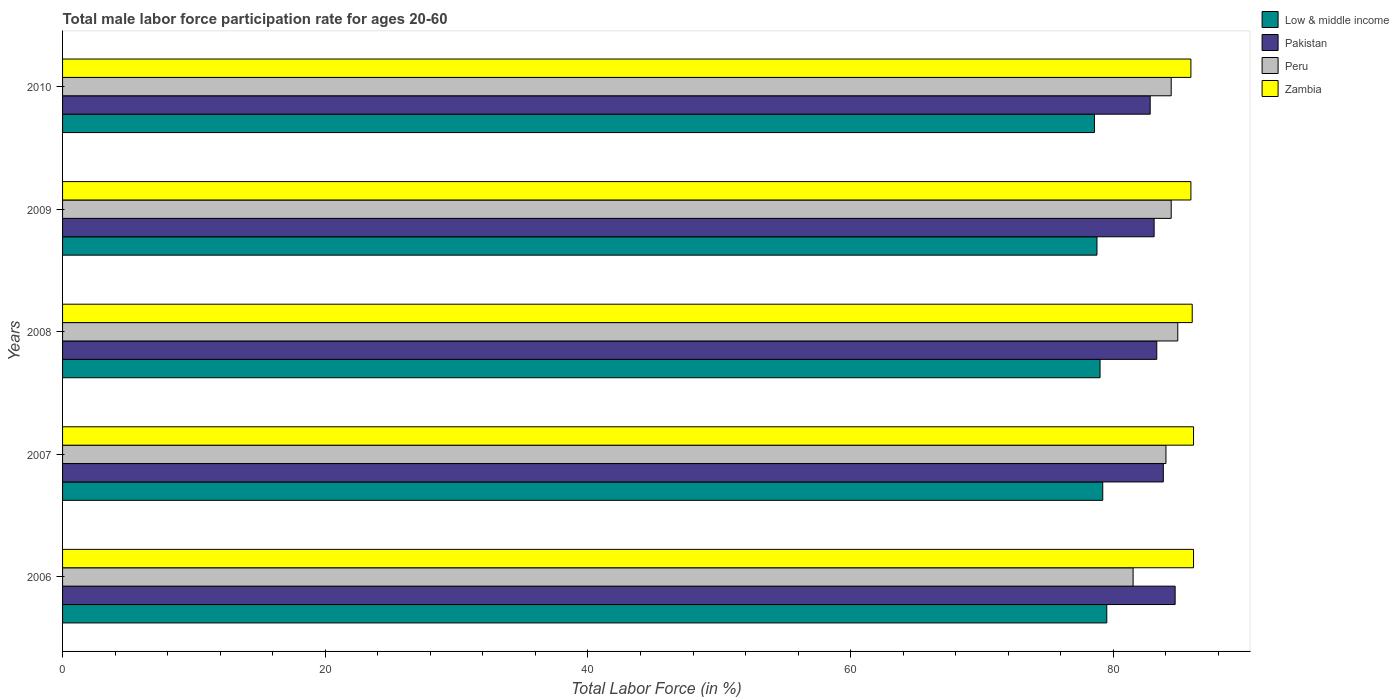How many different coloured bars are there?
Your answer should be very brief. 4. What is the label of the 4th group of bars from the top?
Offer a very short reply. 2007. What is the male labor force participation rate in Zambia in 2010?
Ensure brevity in your answer.  85.9. Across all years, what is the maximum male labor force participation rate in Peru?
Your answer should be compact. 84.9. Across all years, what is the minimum male labor force participation rate in Low & middle income?
Make the answer very short. 78.55. What is the total male labor force participation rate in Low & middle income in the graph?
Provide a short and direct response. 394.97. What is the difference between the male labor force participation rate in Zambia in 2008 and that in 2009?
Ensure brevity in your answer.  0.1. What is the difference between the male labor force participation rate in Zambia in 2008 and the male labor force participation rate in Pakistan in 2007?
Give a very brief answer. 2.2. What is the average male labor force participation rate in Peru per year?
Offer a terse response. 83.84. In the year 2007, what is the difference between the male labor force participation rate in Peru and male labor force participation rate in Zambia?
Your answer should be very brief. -2.1. What is the ratio of the male labor force participation rate in Pakistan in 2006 to that in 2008?
Keep it short and to the point. 1.02. What is the difference between the highest and the lowest male labor force participation rate in Zambia?
Make the answer very short. 0.2. In how many years, is the male labor force participation rate in Peru greater than the average male labor force participation rate in Peru taken over all years?
Your answer should be compact. 4. Is the sum of the male labor force participation rate in Low & middle income in 2006 and 2007 greater than the maximum male labor force participation rate in Pakistan across all years?
Give a very brief answer. Yes. Is it the case that in every year, the sum of the male labor force participation rate in Zambia and male labor force participation rate in Pakistan is greater than the sum of male labor force participation rate in Low & middle income and male labor force participation rate in Peru?
Your answer should be very brief. No. What does the 1st bar from the top in 2006 represents?
Provide a succinct answer. Zambia. What does the 4th bar from the bottom in 2007 represents?
Offer a very short reply. Zambia. Are all the bars in the graph horizontal?
Provide a succinct answer. Yes. How many years are there in the graph?
Your response must be concise. 5. What is the difference between two consecutive major ticks on the X-axis?
Offer a very short reply. 20. Are the values on the major ticks of X-axis written in scientific E-notation?
Your answer should be very brief. No. Does the graph contain grids?
Offer a terse response. No. How many legend labels are there?
Keep it short and to the point. 4. How are the legend labels stacked?
Give a very brief answer. Vertical. What is the title of the graph?
Your response must be concise. Total male labor force participation rate for ages 20-60. What is the label or title of the X-axis?
Ensure brevity in your answer.  Total Labor Force (in %). What is the label or title of the Y-axis?
Your answer should be very brief. Years. What is the Total Labor Force (in %) in Low & middle income in 2006?
Offer a very short reply. 79.5. What is the Total Labor Force (in %) of Pakistan in 2006?
Offer a terse response. 84.7. What is the Total Labor Force (in %) in Peru in 2006?
Keep it short and to the point. 81.5. What is the Total Labor Force (in %) of Zambia in 2006?
Your response must be concise. 86.1. What is the Total Labor Force (in %) in Low & middle income in 2007?
Offer a very short reply. 79.19. What is the Total Labor Force (in %) in Pakistan in 2007?
Offer a very short reply. 83.8. What is the Total Labor Force (in %) of Peru in 2007?
Make the answer very short. 84. What is the Total Labor Force (in %) in Zambia in 2007?
Ensure brevity in your answer.  86.1. What is the Total Labor Force (in %) of Low & middle income in 2008?
Your answer should be very brief. 78.98. What is the Total Labor Force (in %) in Pakistan in 2008?
Offer a very short reply. 83.3. What is the Total Labor Force (in %) of Peru in 2008?
Your answer should be very brief. 84.9. What is the Total Labor Force (in %) of Zambia in 2008?
Your answer should be very brief. 86. What is the Total Labor Force (in %) of Low & middle income in 2009?
Your answer should be compact. 78.75. What is the Total Labor Force (in %) in Pakistan in 2009?
Provide a short and direct response. 83.1. What is the Total Labor Force (in %) of Peru in 2009?
Your answer should be compact. 84.4. What is the Total Labor Force (in %) in Zambia in 2009?
Your answer should be very brief. 85.9. What is the Total Labor Force (in %) of Low & middle income in 2010?
Provide a succinct answer. 78.55. What is the Total Labor Force (in %) of Pakistan in 2010?
Provide a succinct answer. 82.8. What is the Total Labor Force (in %) in Peru in 2010?
Make the answer very short. 84.4. What is the Total Labor Force (in %) of Zambia in 2010?
Make the answer very short. 85.9. Across all years, what is the maximum Total Labor Force (in %) in Low & middle income?
Provide a succinct answer. 79.5. Across all years, what is the maximum Total Labor Force (in %) in Pakistan?
Offer a very short reply. 84.7. Across all years, what is the maximum Total Labor Force (in %) in Peru?
Provide a succinct answer. 84.9. Across all years, what is the maximum Total Labor Force (in %) in Zambia?
Make the answer very short. 86.1. Across all years, what is the minimum Total Labor Force (in %) of Low & middle income?
Offer a terse response. 78.55. Across all years, what is the minimum Total Labor Force (in %) of Pakistan?
Offer a terse response. 82.8. Across all years, what is the minimum Total Labor Force (in %) of Peru?
Offer a terse response. 81.5. Across all years, what is the minimum Total Labor Force (in %) of Zambia?
Your response must be concise. 85.9. What is the total Total Labor Force (in %) in Low & middle income in the graph?
Keep it short and to the point. 394.97. What is the total Total Labor Force (in %) in Pakistan in the graph?
Your response must be concise. 417.7. What is the total Total Labor Force (in %) in Peru in the graph?
Keep it short and to the point. 419.2. What is the total Total Labor Force (in %) of Zambia in the graph?
Give a very brief answer. 430. What is the difference between the Total Labor Force (in %) of Low & middle income in 2006 and that in 2007?
Ensure brevity in your answer.  0.31. What is the difference between the Total Labor Force (in %) of Pakistan in 2006 and that in 2007?
Give a very brief answer. 0.9. What is the difference between the Total Labor Force (in %) in Zambia in 2006 and that in 2007?
Your response must be concise. 0. What is the difference between the Total Labor Force (in %) in Low & middle income in 2006 and that in 2008?
Your answer should be very brief. 0.51. What is the difference between the Total Labor Force (in %) of Peru in 2006 and that in 2008?
Make the answer very short. -3.4. What is the difference between the Total Labor Force (in %) of Low & middle income in 2006 and that in 2009?
Provide a succinct answer. 0.75. What is the difference between the Total Labor Force (in %) of Pakistan in 2006 and that in 2009?
Your answer should be compact. 1.6. What is the difference between the Total Labor Force (in %) of Zambia in 2006 and that in 2009?
Your response must be concise. 0.2. What is the difference between the Total Labor Force (in %) in Low & middle income in 2006 and that in 2010?
Provide a succinct answer. 0.94. What is the difference between the Total Labor Force (in %) in Pakistan in 2006 and that in 2010?
Provide a succinct answer. 1.9. What is the difference between the Total Labor Force (in %) of Low & middle income in 2007 and that in 2008?
Offer a very short reply. 0.2. What is the difference between the Total Labor Force (in %) in Pakistan in 2007 and that in 2008?
Offer a terse response. 0.5. What is the difference between the Total Labor Force (in %) in Zambia in 2007 and that in 2008?
Ensure brevity in your answer.  0.1. What is the difference between the Total Labor Force (in %) of Low & middle income in 2007 and that in 2009?
Your answer should be very brief. 0.44. What is the difference between the Total Labor Force (in %) in Peru in 2007 and that in 2009?
Keep it short and to the point. -0.4. What is the difference between the Total Labor Force (in %) of Low & middle income in 2007 and that in 2010?
Provide a short and direct response. 0.63. What is the difference between the Total Labor Force (in %) of Low & middle income in 2008 and that in 2009?
Your answer should be compact. 0.23. What is the difference between the Total Labor Force (in %) in Peru in 2008 and that in 2009?
Give a very brief answer. 0.5. What is the difference between the Total Labor Force (in %) of Low & middle income in 2008 and that in 2010?
Give a very brief answer. 0.43. What is the difference between the Total Labor Force (in %) of Pakistan in 2008 and that in 2010?
Make the answer very short. 0.5. What is the difference between the Total Labor Force (in %) in Peru in 2008 and that in 2010?
Provide a short and direct response. 0.5. What is the difference between the Total Labor Force (in %) in Low & middle income in 2009 and that in 2010?
Your answer should be very brief. 0.19. What is the difference between the Total Labor Force (in %) of Zambia in 2009 and that in 2010?
Offer a very short reply. 0. What is the difference between the Total Labor Force (in %) in Low & middle income in 2006 and the Total Labor Force (in %) in Pakistan in 2007?
Ensure brevity in your answer.  -4.3. What is the difference between the Total Labor Force (in %) in Low & middle income in 2006 and the Total Labor Force (in %) in Peru in 2007?
Your answer should be very brief. -4.5. What is the difference between the Total Labor Force (in %) in Low & middle income in 2006 and the Total Labor Force (in %) in Zambia in 2007?
Make the answer very short. -6.6. What is the difference between the Total Labor Force (in %) in Pakistan in 2006 and the Total Labor Force (in %) in Zambia in 2007?
Your answer should be compact. -1.4. What is the difference between the Total Labor Force (in %) in Peru in 2006 and the Total Labor Force (in %) in Zambia in 2007?
Offer a very short reply. -4.6. What is the difference between the Total Labor Force (in %) in Low & middle income in 2006 and the Total Labor Force (in %) in Pakistan in 2008?
Ensure brevity in your answer.  -3.8. What is the difference between the Total Labor Force (in %) of Low & middle income in 2006 and the Total Labor Force (in %) of Peru in 2008?
Ensure brevity in your answer.  -5.4. What is the difference between the Total Labor Force (in %) of Low & middle income in 2006 and the Total Labor Force (in %) of Zambia in 2008?
Provide a short and direct response. -6.5. What is the difference between the Total Labor Force (in %) in Pakistan in 2006 and the Total Labor Force (in %) in Peru in 2008?
Offer a very short reply. -0.2. What is the difference between the Total Labor Force (in %) of Pakistan in 2006 and the Total Labor Force (in %) of Zambia in 2008?
Keep it short and to the point. -1.3. What is the difference between the Total Labor Force (in %) in Low & middle income in 2006 and the Total Labor Force (in %) in Pakistan in 2009?
Provide a short and direct response. -3.6. What is the difference between the Total Labor Force (in %) in Low & middle income in 2006 and the Total Labor Force (in %) in Peru in 2009?
Offer a terse response. -4.9. What is the difference between the Total Labor Force (in %) of Low & middle income in 2006 and the Total Labor Force (in %) of Zambia in 2009?
Your response must be concise. -6.4. What is the difference between the Total Labor Force (in %) in Pakistan in 2006 and the Total Labor Force (in %) in Zambia in 2009?
Offer a very short reply. -1.2. What is the difference between the Total Labor Force (in %) in Low & middle income in 2006 and the Total Labor Force (in %) in Pakistan in 2010?
Offer a terse response. -3.3. What is the difference between the Total Labor Force (in %) in Low & middle income in 2006 and the Total Labor Force (in %) in Peru in 2010?
Offer a very short reply. -4.9. What is the difference between the Total Labor Force (in %) of Low & middle income in 2006 and the Total Labor Force (in %) of Zambia in 2010?
Your answer should be very brief. -6.4. What is the difference between the Total Labor Force (in %) of Pakistan in 2006 and the Total Labor Force (in %) of Zambia in 2010?
Your answer should be compact. -1.2. What is the difference between the Total Labor Force (in %) of Low & middle income in 2007 and the Total Labor Force (in %) of Pakistan in 2008?
Keep it short and to the point. -4.11. What is the difference between the Total Labor Force (in %) in Low & middle income in 2007 and the Total Labor Force (in %) in Peru in 2008?
Offer a very short reply. -5.71. What is the difference between the Total Labor Force (in %) of Low & middle income in 2007 and the Total Labor Force (in %) of Zambia in 2008?
Ensure brevity in your answer.  -6.81. What is the difference between the Total Labor Force (in %) in Pakistan in 2007 and the Total Labor Force (in %) in Peru in 2008?
Provide a succinct answer. -1.1. What is the difference between the Total Labor Force (in %) in Peru in 2007 and the Total Labor Force (in %) in Zambia in 2008?
Your answer should be compact. -2. What is the difference between the Total Labor Force (in %) of Low & middle income in 2007 and the Total Labor Force (in %) of Pakistan in 2009?
Your answer should be compact. -3.91. What is the difference between the Total Labor Force (in %) of Low & middle income in 2007 and the Total Labor Force (in %) of Peru in 2009?
Keep it short and to the point. -5.21. What is the difference between the Total Labor Force (in %) of Low & middle income in 2007 and the Total Labor Force (in %) of Zambia in 2009?
Offer a very short reply. -6.71. What is the difference between the Total Labor Force (in %) of Pakistan in 2007 and the Total Labor Force (in %) of Zambia in 2009?
Offer a very short reply. -2.1. What is the difference between the Total Labor Force (in %) in Low & middle income in 2007 and the Total Labor Force (in %) in Pakistan in 2010?
Your response must be concise. -3.61. What is the difference between the Total Labor Force (in %) of Low & middle income in 2007 and the Total Labor Force (in %) of Peru in 2010?
Offer a terse response. -5.21. What is the difference between the Total Labor Force (in %) of Low & middle income in 2007 and the Total Labor Force (in %) of Zambia in 2010?
Provide a succinct answer. -6.71. What is the difference between the Total Labor Force (in %) in Peru in 2007 and the Total Labor Force (in %) in Zambia in 2010?
Make the answer very short. -1.9. What is the difference between the Total Labor Force (in %) in Low & middle income in 2008 and the Total Labor Force (in %) in Pakistan in 2009?
Offer a terse response. -4.12. What is the difference between the Total Labor Force (in %) in Low & middle income in 2008 and the Total Labor Force (in %) in Peru in 2009?
Make the answer very short. -5.42. What is the difference between the Total Labor Force (in %) in Low & middle income in 2008 and the Total Labor Force (in %) in Zambia in 2009?
Give a very brief answer. -6.92. What is the difference between the Total Labor Force (in %) of Pakistan in 2008 and the Total Labor Force (in %) of Peru in 2009?
Provide a short and direct response. -1.1. What is the difference between the Total Labor Force (in %) in Peru in 2008 and the Total Labor Force (in %) in Zambia in 2009?
Give a very brief answer. -1. What is the difference between the Total Labor Force (in %) in Low & middle income in 2008 and the Total Labor Force (in %) in Pakistan in 2010?
Provide a succinct answer. -3.82. What is the difference between the Total Labor Force (in %) of Low & middle income in 2008 and the Total Labor Force (in %) of Peru in 2010?
Your answer should be compact. -5.42. What is the difference between the Total Labor Force (in %) of Low & middle income in 2008 and the Total Labor Force (in %) of Zambia in 2010?
Your response must be concise. -6.92. What is the difference between the Total Labor Force (in %) in Pakistan in 2008 and the Total Labor Force (in %) in Peru in 2010?
Your answer should be very brief. -1.1. What is the difference between the Total Labor Force (in %) in Pakistan in 2008 and the Total Labor Force (in %) in Zambia in 2010?
Keep it short and to the point. -2.6. What is the difference between the Total Labor Force (in %) in Low & middle income in 2009 and the Total Labor Force (in %) in Pakistan in 2010?
Your answer should be compact. -4.05. What is the difference between the Total Labor Force (in %) in Low & middle income in 2009 and the Total Labor Force (in %) in Peru in 2010?
Your response must be concise. -5.65. What is the difference between the Total Labor Force (in %) of Low & middle income in 2009 and the Total Labor Force (in %) of Zambia in 2010?
Make the answer very short. -7.15. What is the difference between the Total Labor Force (in %) of Peru in 2009 and the Total Labor Force (in %) of Zambia in 2010?
Give a very brief answer. -1.5. What is the average Total Labor Force (in %) of Low & middle income per year?
Give a very brief answer. 78.99. What is the average Total Labor Force (in %) in Pakistan per year?
Make the answer very short. 83.54. What is the average Total Labor Force (in %) in Peru per year?
Provide a short and direct response. 83.84. What is the average Total Labor Force (in %) in Zambia per year?
Keep it short and to the point. 86. In the year 2006, what is the difference between the Total Labor Force (in %) in Low & middle income and Total Labor Force (in %) in Pakistan?
Make the answer very short. -5.2. In the year 2006, what is the difference between the Total Labor Force (in %) in Low & middle income and Total Labor Force (in %) in Peru?
Your response must be concise. -2. In the year 2006, what is the difference between the Total Labor Force (in %) of Low & middle income and Total Labor Force (in %) of Zambia?
Keep it short and to the point. -6.6. In the year 2007, what is the difference between the Total Labor Force (in %) in Low & middle income and Total Labor Force (in %) in Pakistan?
Provide a succinct answer. -4.61. In the year 2007, what is the difference between the Total Labor Force (in %) of Low & middle income and Total Labor Force (in %) of Peru?
Ensure brevity in your answer.  -4.81. In the year 2007, what is the difference between the Total Labor Force (in %) in Low & middle income and Total Labor Force (in %) in Zambia?
Your answer should be very brief. -6.91. In the year 2007, what is the difference between the Total Labor Force (in %) of Pakistan and Total Labor Force (in %) of Zambia?
Keep it short and to the point. -2.3. In the year 2007, what is the difference between the Total Labor Force (in %) in Peru and Total Labor Force (in %) in Zambia?
Your answer should be very brief. -2.1. In the year 2008, what is the difference between the Total Labor Force (in %) of Low & middle income and Total Labor Force (in %) of Pakistan?
Provide a succinct answer. -4.32. In the year 2008, what is the difference between the Total Labor Force (in %) of Low & middle income and Total Labor Force (in %) of Peru?
Make the answer very short. -5.92. In the year 2008, what is the difference between the Total Labor Force (in %) of Low & middle income and Total Labor Force (in %) of Zambia?
Offer a terse response. -7.02. In the year 2009, what is the difference between the Total Labor Force (in %) in Low & middle income and Total Labor Force (in %) in Pakistan?
Give a very brief answer. -4.35. In the year 2009, what is the difference between the Total Labor Force (in %) of Low & middle income and Total Labor Force (in %) of Peru?
Your answer should be very brief. -5.65. In the year 2009, what is the difference between the Total Labor Force (in %) of Low & middle income and Total Labor Force (in %) of Zambia?
Provide a succinct answer. -7.15. In the year 2009, what is the difference between the Total Labor Force (in %) of Pakistan and Total Labor Force (in %) of Zambia?
Keep it short and to the point. -2.8. In the year 2010, what is the difference between the Total Labor Force (in %) of Low & middle income and Total Labor Force (in %) of Pakistan?
Keep it short and to the point. -4.25. In the year 2010, what is the difference between the Total Labor Force (in %) in Low & middle income and Total Labor Force (in %) in Peru?
Your answer should be compact. -5.85. In the year 2010, what is the difference between the Total Labor Force (in %) in Low & middle income and Total Labor Force (in %) in Zambia?
Your answer should be very brief. -7.35. In the year 2010, what is the difference between the Total Labor Force (in %) in Pakistan and Total Labor Force (in %) in Zambia?
Your response must be concise. -3.1. In the year 2010, what is the difference between the Total Labor Force (in %) of Peru and Total Labor Force (in %) of Zambia?
Give a very brief answer. -1.5. What is the ratio of the Total Labor Force (in %) of Low & middle income in 2006 to that in 2007?
Ensure brevity in your answer.  1. What is the ratio of the Total Labor Force (in %) in Pakistan in 2006 to that in 2007?
Your response must be concise. 1.01. What is the ratio of the Total Labor Force (in %) of Peru in 2006 to that in 2007?
Ensure brevity in your answer.  0.97. What is the ratio of the Total Labor Force (in %) in Pakistan in 2006 to that in 2008?
Provide a succinct answer. 1.02. What is the ratio of the Total Labor Force (in %) of Peru in 2006 to that in 2008?
Keep it short and to the point. 0.96. What is the ratio of the Total Labor Force (in %) of Low & middle income in 2006 to that in 2009?
Keep it short and to the point. 1.01. What is the ratio of the Total Labor Force (in %) in Pakistan in 2006 to that in 2009?
Offer a terse response. 1.02. What is the ratio of the Total Labor Force (in %) of Peru in 2006 to that in 2009?
Make the answer very short. 0.97. What is the ratio of the Total Labor Force (in %) in Pakistan in 2006 to that in 2010?
Make the answer very short. 1.02. What is the ratio of the Total Labor Force (in %) of Peru in 2006 to that in 2010?
Make the answer very short. 0.97. What is the ratio of the Total Labor Force (in %) in Zambia in 2006 to that in 2010?
Keep it short and to the point. 1. What is the ratio of the Total Labor Force (in %) of Low & middle income in 2007 to that in 2008?
Ensure brevity in your answer.  1. What is the ratio of the Total Labor Force (in %) of Pakistan in 2007 to that in 2008?
Offer a terse response. 1.01. What is the ratio of the Total Labor Force (in %) of Peru in 2007 to that in 2008?
Your answer should be very brief. 0.99. What is the ratio of the Total Labor Force (in %) of Low & middle income in 2007 to that in 2009?
Your answer should be very brief. 1.01. What is the ratio of the Total Labor Force (in %) of Pakistan in 2007 to that in 2009?
Your answer should be very brief. 1.01. What is the ratio of the Total Labor Force (in %) of Zambia in 2007 to that in 2009?
Offer a very short reply. 1. What is the ratio of the Total Labor Force (in %) of Low & middle income in 2007 to that in 2010?
Offer a very short reply. 1.01. What is the ratio of the Total Labor Force (in %) of Pakistan in 2007 to that in 2010?
Provide a succinct answer. 1.01. What is the ratio of the Total Labor Force (in %) in Low & middle income in 2008 to that in 2009?
Your answer should be compact. 1. What is the ratio of the Total Labor Force (in %) in Peru in 2008 to that in 2009?
Keep it short and to the point. 1.01. What is the ratio of the Total Labor Force (in %) in Peru in 2008 to that in 2010?
Give a very brief answer. 1.01. What is the ratio of the Total Labor Force (in %) in Zambia in 2008 to that in 2010?
Keep it short and to the point. 1. What is the ratio of the Total Labor Force (in %) in Peru in 2009 to that in 2010?
Your answer should be very brief. 1. What is the ratio of the Total Labor Force (in %) of Zambia in 2009 to that in 2010?
Keep it short and to the point. 1. What is the difference between the highest and the second highest Total Labor Force (in %) in Low & middle income?
Your answer should be very brief. 0.31. What is the difference between the highest and the second highest Total Labor Force (in %) of Pakistan?
Your response must be concise. 0.9. What is the difference between the highest and the second highest Total Labor Force (in %) in Zambia?
Offer a terse response. 0. What is the difference between the highest and the lowest Total Labor Force (in %) in Low & middle income?
Give a very brief answer. 0.94. What is the difference between the highest and the lowest Total Labor Force (in %) of Peru?
Offer a very short reply. 3.4. What is the difference between the highest and the lowest Total Labor Force (in %) of Zambia?
Make the answer very short. 0.2. 